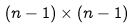<formula> <loc_0><loc_0><loc_500><loc_500>( n - 1 ) \times ( n - 1 )</formula> 